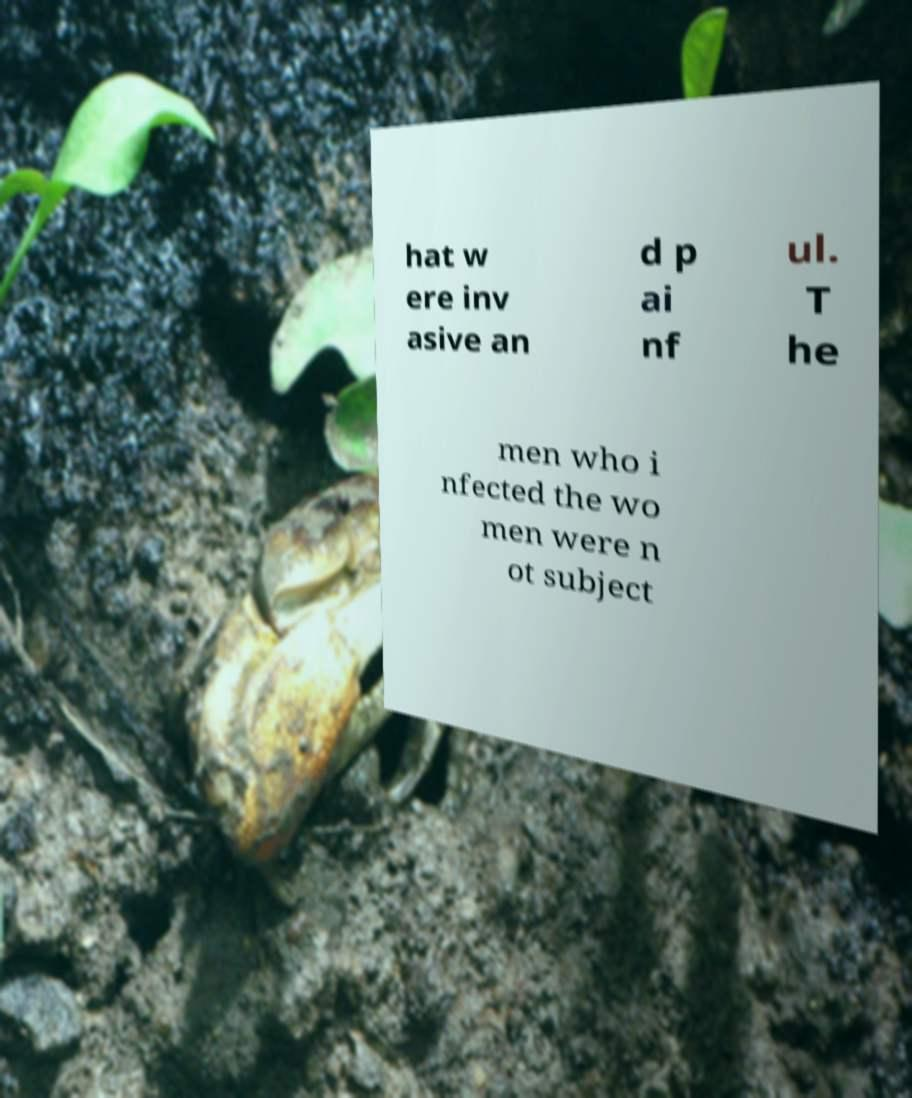For documentation purposes, I need the text within this image transcribed. Could you provide that? hat w ere inv asive an d p ai nf ul. T he men who i nfected the wo men were n ot subject 